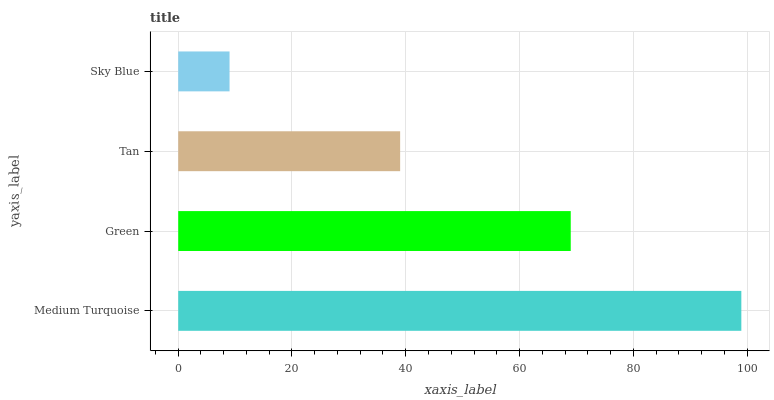Is Sky Blue the minimum?
Answer yes or no. Yes. Is Medium Turquoise the maximum?
Answer yes or no. Yes. Is Green the minimum?
Answer yes or no. No. Is Green the maximum?
Answer yes or no. No. Is Medium Turquoise greater than Green?
Answer yes or no. Yes. Is Green less than Medium Turquoise?
Answer yes or no. Yes. Is Green greater than Medium Turquoise?
Answer yes or no. No. Is Medium Turquoise less than Green?
Answer yes or no. No. Is Green the high median?
Answer yes or no. Yes. Is Tan the low median?
Answer yes or no. Yes. Is Sky Blue the high median?
Answer yes or no. No. Is Medium Turquoise the low median?
Answer yes or no. No. 